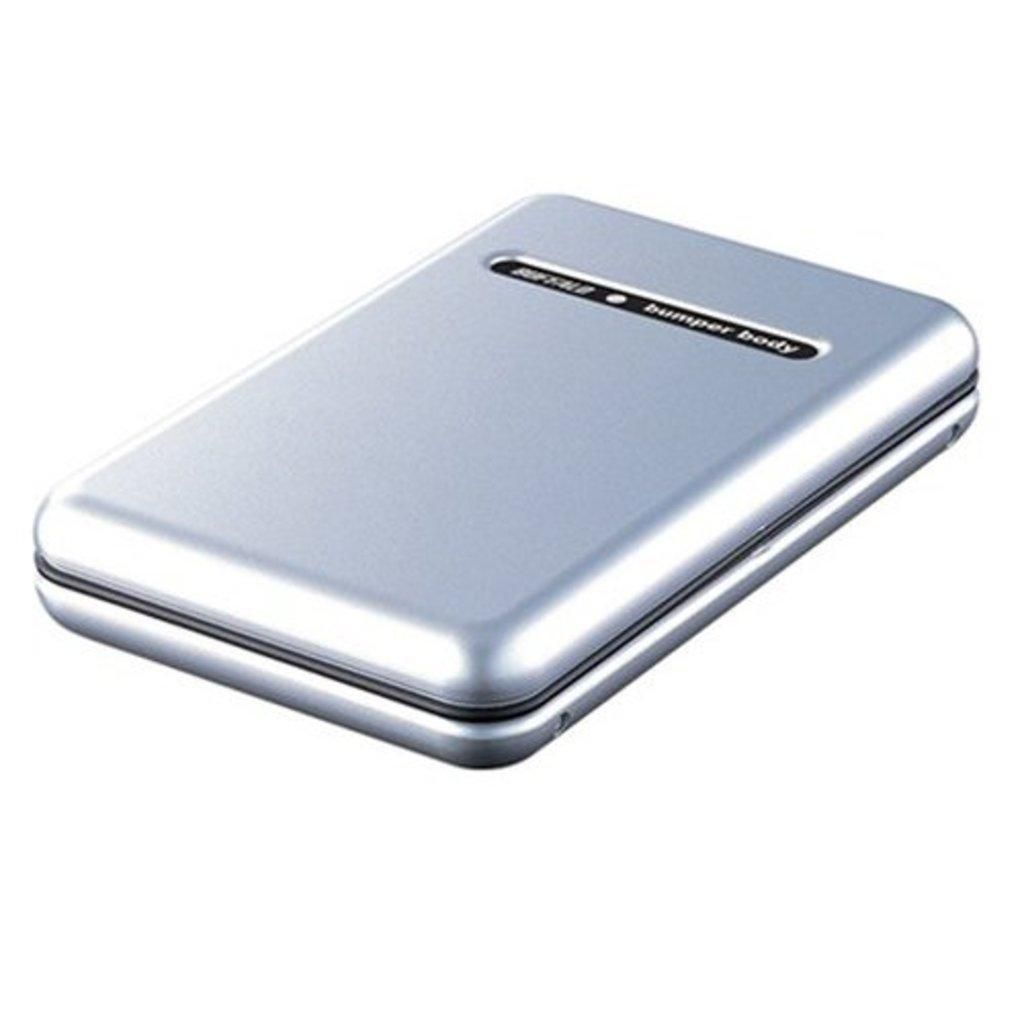<image>
Share a concise interpretation of the image provided. A silver case that says bumper body on it is displayed against a white background. 